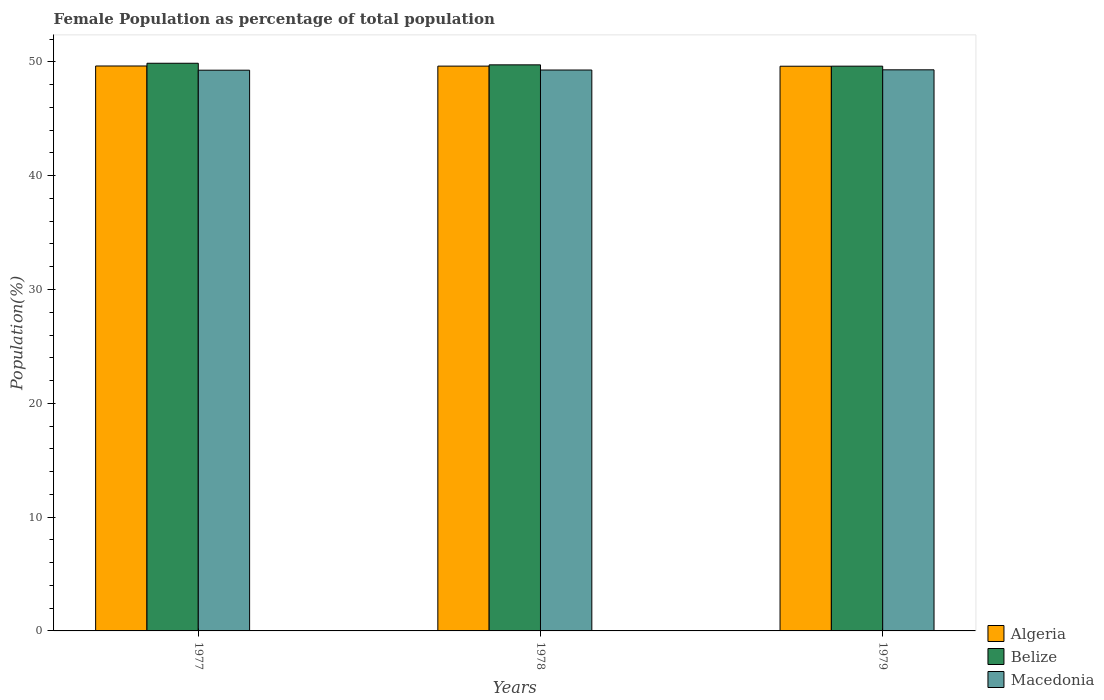How many different coloured bars are there?
Provide a short and direct response. 3. How many groups of bars are there?
Your answer should be very brief. 3. Are the number of bars on each tick of the X-axis equal?
Offer a very short reply. Yes. How many bars are there on the 1st tick from the right?
Provide a short and direct response. 3. In how many cases, is the number of bars for a given year not equal to the number of legend labels?
Offer a terse response. 0. What is the female population in in Belize in 1979?
Your response must be concise. 49.62. Across all years, what is the maximum female population in in Macedonia?
Provide a short and direct response. 49.3. Across all years, what is the minimum female population in in Macedonia?
Offer a very short reply. 49.27. In which year was the female population in in Algeria minimum?
Provide a succinct answer. 1979. What is the total female population in in Macedonia in the graph?
Give a very brief answer. 147.85. What is the difference between the female population in in Belize in 1977 and that in 1979?
Offer a very short reply. 0.26. What is the difference between the female population in in Algeria in 1977 and the female population in in Macedonia in 1978?
Make the answer very short. 0.36. What is the average female population in in Macedonia per year?
Provide a succinct answer. 49.28. In the year 1977, what is the difference between the female population in in Macedonia and female population in in Belize?
Give a very brief answer. -0.61. In how many years, is the female population in in Macedonia greater than 32 %?
Your answer should be compact. 3. What is the ratio of the female population in in Algeria in 1977 to that in 1979?
Give a very brief answer. 1. Is the difference between the female population in in Macedonia in 1977 and 1978 greater than the difference between the female population in in Belize in 1977 and 1978?
Provide a succinct answer. No. What is the difference between the highest and the second highest female population in in Macedonia?
Provide a succinct answer. 0.02. What is the difference between the highest and the lowest female population in in Algeria?
Give a very brief answer. 0.02. Is the sum of the female population in in Belize in 1978 and 1979 greater than the maximum female population in in Macedonia across all years?
Make the answer very short. Yes. What does the 3rd bar from the left in 1979 represents?
Keep it short and to the point. Macedonia. What does the 2nd bar from the right in 1978 represents?
Keep it short and to the point. Belize. What is the difference between two consecutive major ticks on the Y-axis?
Keep it short and to the point. 10. Does the graph contain grids?
Give a very brief answer. No. How are the legend labels stacked?
Offer a terse response. Vertical. What is the title of the graph?
Provide a succinct answer. Female Population as percentage of total population. What is the label or title of the X-axis?
Make the answer very short. Years. What is the label or title of the Y-axis?
Make the answer very short. Population(%). What is the Population(%) in Algeria in 1977?
Offer a very short reply. 49.64. What is the Population(%) in Belize in 1977?
Ensure brevity in your answer.  49.88. What is the Population(%) in Macedonia in 1977?
Offer a terse response. 49.27. What is the Population(%) in Algeria in 1978?
Keep it short and to the point. 49.63. What is the Population(%) in Belize in 1978?
Give a very brief answer. 49.74. What is the Population(%) of Macedonia in 1978?
Ensure brevity in your answer.  49.28. What is the Population(%) of Algeria in 1979?
Make the answer very short. 49.62. What is the Population(%) of Belize in 1979?
Keep it short and to the point. 49.62. What is the Population(%) of Macedonia in 1979?
Your answer should be compact. 49.3. Across all years, what is the maximum Population(%) in Algeria?
Your response must be concise. 49.64. Across all years, what is the maximum Population(%) in Belize?
Your answer should be very brief. 49.88. Across all years, what is the maximum Population(%) in Macedonia?
Keep it short and to the point. 49.3. Across all years, what is the minimum Population(%) of Algeria?
Your answer should be compact. 49.62. Across all years, what is the minimum Population(%) in Belize?
Offer a terse response. 49.62. Across all years, what is the minimum Population(%) in Macedonia?
Provide a succinct answer. 49.27. What is the total Population(%) in Algeria in the graph?
Offer a terse response. 148.88. What is the total Population(%) in Belize in the graph?
Give a very brief answer. 149.24. What is the total Population(%) in Macedonia in the graph?
Your answer should be compact. 147.85. What is the difference between the Population(%) in Algeria in 1977 and that in 1978?
Provide a short and direct response. 0.01. What is the difference between the Population(%) in Belize in 1977 and that in 1978?
Make the answer very short. 0.14. What is the difference between the Population(%) of Macedonia in 1977 and that in 1978?
Ensure brevity in your answer.  -0.01. What is the difference between the Population(%) of Algeria in 1977 and that in 1979?
Make the answer very short. 0.02. What is the difference between the Population(%) in Belize in 1977 and that in 1979?
Offer a terse response. 0.26. What is the difference between the Population(%) of Macedonia in 1977 and that in 1979?
Make the answer very short. -0.03. What is the difference between the Population(%) in Algeria in 1978 and that in 1979?
Your answer should be very brief. 0.01. What is the difference between the Population(%) of Belize in 1978 and that in 1979?
Keep it short and to the point. 0.12. What is the difference between the Population(%) of Macedonia in 1978 and that in 1979?
Give a very brief answer. -0.02. What is the difference between the Population(%) of Algeria in 1977 and the Population(%) of Belize in 1978?
Your response must be concise. -0.1. What is the difference between the Population(%) in Algeria in 1977 and the Population(%) in Macedonia in 1978?
Provide a succinct answer. 0.36. What is the difference between the Population(%) of Belize in 1977 and the Population(%) of Macedonia in 1978?
Provide a succinct answer. 0.59. What is the difference between the Population(%) in Algeria in 1977 and the Population(%) in Belize in 1979?
Provide a succinct answer. 0.02. What is the difference between the Population(%) of Algeria in 1977 and the Population(%) of Macedonia in 1979?
Your response must be concise. 0.34. What is the difference between the Population(%) in Belize in 1977 and the Population(%) in Macedonia in 1979?
Offer a terse response. 0.58. What is the difference between the Population(%) in Algeria in 1978 and the Population(%) in Belize in 1979?
Ensure brevity in your answer.  0.01. What is the difference between the Population(%) in Algeria in 1978 and the Population(%) in Macedonia in 1979?
Make the answer very short. 0.33. What is the difference between the Population(%) of Belize in 1978 and the Population(%) of Macedonia in 1979?
Give a very brief answer. 0.44. What is the average Population(%) of Algeria per year?
Your response must be concise. 49.63. What is the average Population(%) of Belize per year?
Make the answer very short. 49.75. What is the average Population(%) in Macedonia per year?
Keep it short and to the point. 49.28. In the year 1977, what is the difference between the Population(%) in Algeria and Population(%) in Belize?
Your response must be concise. -0.24. In the year 1977, what is the difference between the Population(%) in Algeria and Population(%) in Macedonia?
Ensure brevity in your answer.  0.37. In the year 1977, what is the difference between the Population(%) of Belize and Population(%) of Macedonia?
Offer a terse response. 0.61. In the year 1978, what is the difference between the Population(%) in Algeria and Population(%) in Belize?
Offer a terse response. -0.11. In the year 1978, what is the difference between the Population(%) of Algeria and Population(%) of Macedonia?
Ensure brevity in your answer.  0.34. In the year 1978, what is the difference between the Population(%) of Belize and Population(%) of Macedonia?
Provide a short and direct response. 0.46. In the year 1979, what is the difference between the Population(%) in Algeria and Population(%) in Belize?
Ensure brevity in your answer.  -0.01. In the year 1979, what is the difference between the Population(%) in Algeria and Population(%) in Macedonia?
Your answer should be compact. 0.32. In the year 1979, what is the difference between the Population(%) of Belize and Population(%) of Macedonia?
Keep it short and to the point. 0.32. What is the ratio of the Population(%) of Belize in 1977 to that in 1978?
Provide a short and direct response. 1. What is the ratio of the Population(%) of Belize in 1977 to that in 1979?
Keep it short and to the point. 1.01. What is the ratio of the Population(%) in Macedonia in 1977 to that in 1979?
Ensure brevity in your answer.  1. What is the ratio of the Population(%) of Macedonia in 1978 to that in 1979?
Keep it short and to the point. 1. What is the difference between the highest and the second highest Population(%) of Algeria?
Ensure brevity in your answer.  0.01. What is the difference between the highest and the second highest Population(%) of Belize?
Give a very brief answer. 0.14. What is the difference between the highest and the second highest Population(%) in Macedonia?
Provide a succinct answer. 0.02. What is the difference between the highest and the lowest Population(%) in Algeria?
Give a very brief answer. 0.02. What is the difference between the highest and the lowest Population(%) of Belize?
Your answer should be compact. 0.26. What is the difference between the highest and the lowest Population(%) in Macedonia?
Offer a very short reply. 0.03. 